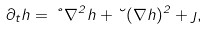Convert formula to latex. <formula><loc_0><loc_0><loc_500><loc_500>\partial _ { t } h = \nu \nabla ^ { 2 } h + \lambda ( \nabla h ) ^ { 2 } + \eta ,</formula> 